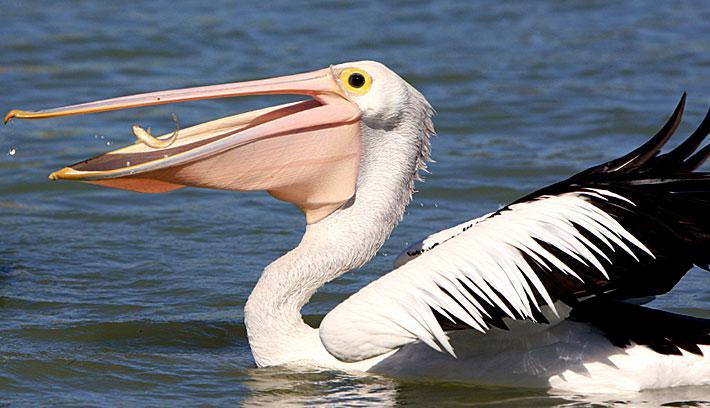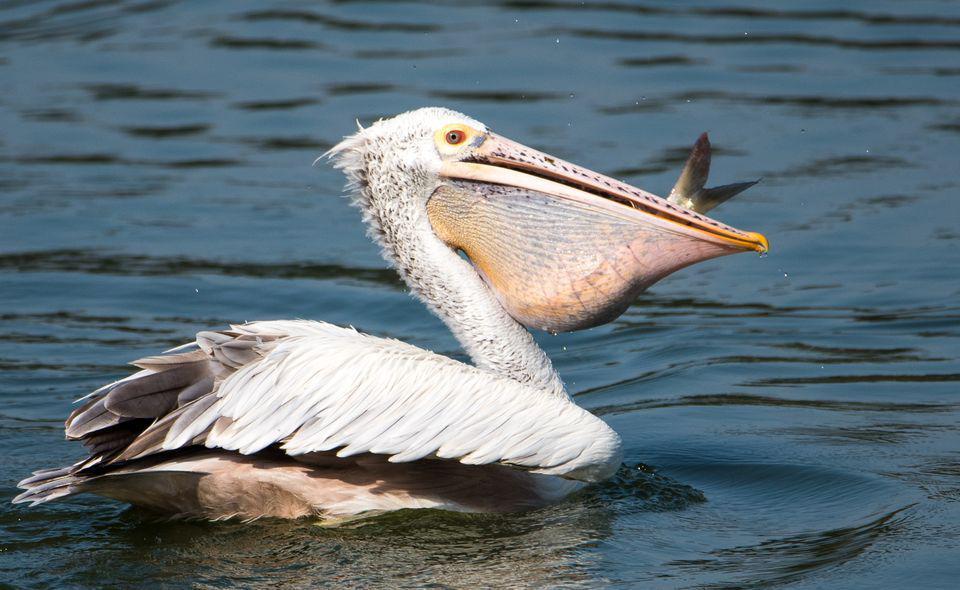The first image is the image on the left, the second image is the image on the right. For the images shown, is this caption "A pelican with wings outstretched has an empty bill." true? Answer yes or no. No. The first image is the image on the left, the second image is the image on the right. For the images shown, is this caption "The bird in the right image is facing towards the left." true? Answer yes or no. No. The first image is the image on the left, the second image is the image on the right. Given the left and right images, does the statement "At least one bird is sitting on water." hold true? Answer yes or no. Yes. 